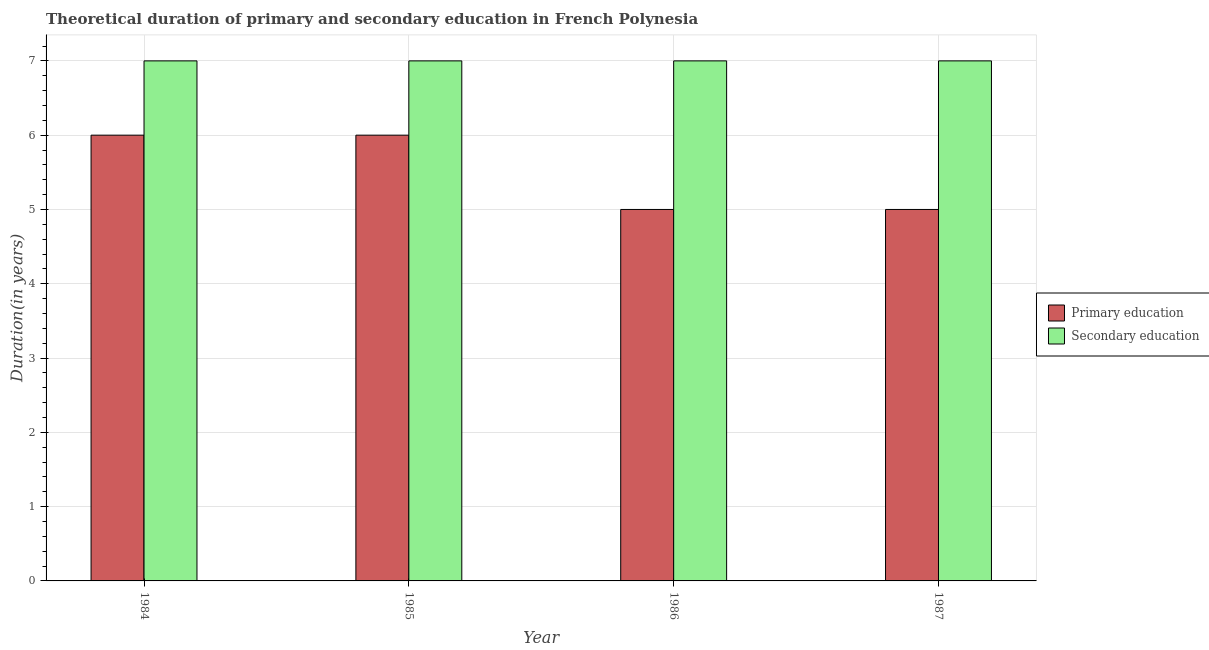Are the number of bars on each tick of the X-axis equal?
Provide a succinct answer. Yes. How many bars are there on the 3rd tick from the left?
Your response must be concise. 2. What is the label of the 2nd group of bars from the left?
Provide a succinct answer. 1985. In how many cases, is the number of bars for a given year not equal to the number of legend labels?
Make the answer very short. 0. What is the duration of primary education in 1984?
Keep it short and to the point. 6. Across all years, what is the maximum duration of secondary education?
Keep it short and to the point. 7. Across all years, what is the minimum duration of primary education?
Offer a very short reply. 5. In which year was the duration of secondary education minimum?
Provide a succinct answer. 1984. What is the total duration of primary education in the graph?
Offer a very short reply. 22. What is the difference between the duration of secondary education in 1984 and that in 1987?
Your response must be concise. 0. What is the average duration of secondary education per year?
Your answer should be compact. 7. In the year 1986, what is the difference between the duration of primary education and duration of secondary education?
Provide a succinct answer. 0. What is the ratio of the duration of primary education in 1984 to that in 1985?
Provide a short and direct response. 1. Is the difference between the duration of secondary education in 1984 and 1987 greater than the difference between the duration of primary education in 1984 and 1987?
Your answer should be very brief. No. In how many years, is the duration of secondary education greater than the average duration of secondary education taken over all years?
Keep it short and to the point. 0. Is the sum of the duration of primary education in 1984 and 1986 greater than the maximum duration of secondary education across all years?
Give a very brief answer. Yes. What does the 1st bar from the right in 1985 represents?
Keep it short and to the point. Secondary education. How many years are there in the graph?
Give a very brief answer. 4. Are the values on the major ticks of Y-axis written in scientific E-notation?
Keep it short and to the point. No. How many legend labels are there?
Give a very brief answer. 2. What is the title of the graph?
Give a very brief answer. Theoretical duration of primary and secondary education in French Polynesia. What is the label or title of the X-axis?
Offer a terse response. Year. What is the label or title of the Y-axis?
Keep it short and to the point. Duration(in years). What is the Duration(in years) in Secondary education in 1984?
Your answer should be compact. 7. What is the Duration(in years) of Secondary education in 1985?
Your answer should be compact. 7. What is the Duration(in years) of Primary education in 1986?
Provide a short and direct response. 5. What is the Duration(in years) in Secondary education in 1986?
Provide a short and direct response. 7. What is the Duration(in years) in Secondary education in 1987?
Keep it short and to the point. 7. Across all years, what is the maximum Duration(in years) of Primary education?
Provide a short and direct response. 6. What is the difference between the Duration(in years) in Primary education in 1984 and that in 1985?
Provide a short and direct response. 0. What is the difference between the Duration(in years) of Secondary education in 1984 and that in 1985?
Keep it short and to the point. 0. What is the difference between the Duration(in years) in Primary education in 1984 and that in 1986?
Your response must be concise. 1. What is the difference between the Duration(in years) in Secondary education in 1984 and that in 1987?
Offer a very short reply. 0. What is the difference between the Duration(in years) of Secondary education in 1985 and that in 1986?
Your response must be concise. 0. What is the difference between the Duration(in years) of Secondary education in 1985 and that in 1987?
Give a very brief answer. 0. What is the difference between the Duration(in years) in Primary education in 1986 and that in 1987?
Give a very brief answer. 0. What is the difference between the Duration(in years) in Primary education in 1984 and the Duration(in years) in Secondary education in 1985?
Your answer should be very brief. -1. What is the difference between the Duration(in years) in Primary education in 1985 and the Duration(in years) in Secondary education in 1987?
Offer a very short reply. -1. What is the average Duration(in years) in Primary education per year?
Your answer should be very brief. 5.5. What is the average Duration(in years) of Secondary education per year?
Offer a very short reply. 7. In the year 1984, what is the difference between the Duration(in years) of Primary education and Duration(in years) of Secondary education?
Your answer should be compact. -1. What is the ratio of the Duration(in years) of Primary education in 1984 to that in 1985?
Offer a very short reply. 1. What is the ratio of the Duration(in years) of Secondary education in 1984 to that in 1985?
Provide a short and direct response. 1. What is the ratio of the Duration(in years) in Primary education in 1984 to that in 1986?
Your answer should be very brief. 1.2. What is the ratio of the Duration(in years) of Primary education in 1984 to that in 1987?
Your answer should be very brief. 1.2. What is the ratio of the Duration(in years) in Secondary education in 1984 to that in 1987?
Ensure brevity in your answer.  1. What is the ratio of the Duration(in years) in Primary education in 1985 to that in 1986?
Provide a short and direct response. 1.2. What is the ratio of the Duration(in years) of Primary education in 1986 to that in 1987?
Offer a very short reply. 1. What is the difference between the highest and the second highest Duration(in years) in Secondary education?
Provide a succinct answer. 0. What is the difference between the highest and the lowest Duration(in years) in Secondary education?
Keep it short and to the point. 0. 